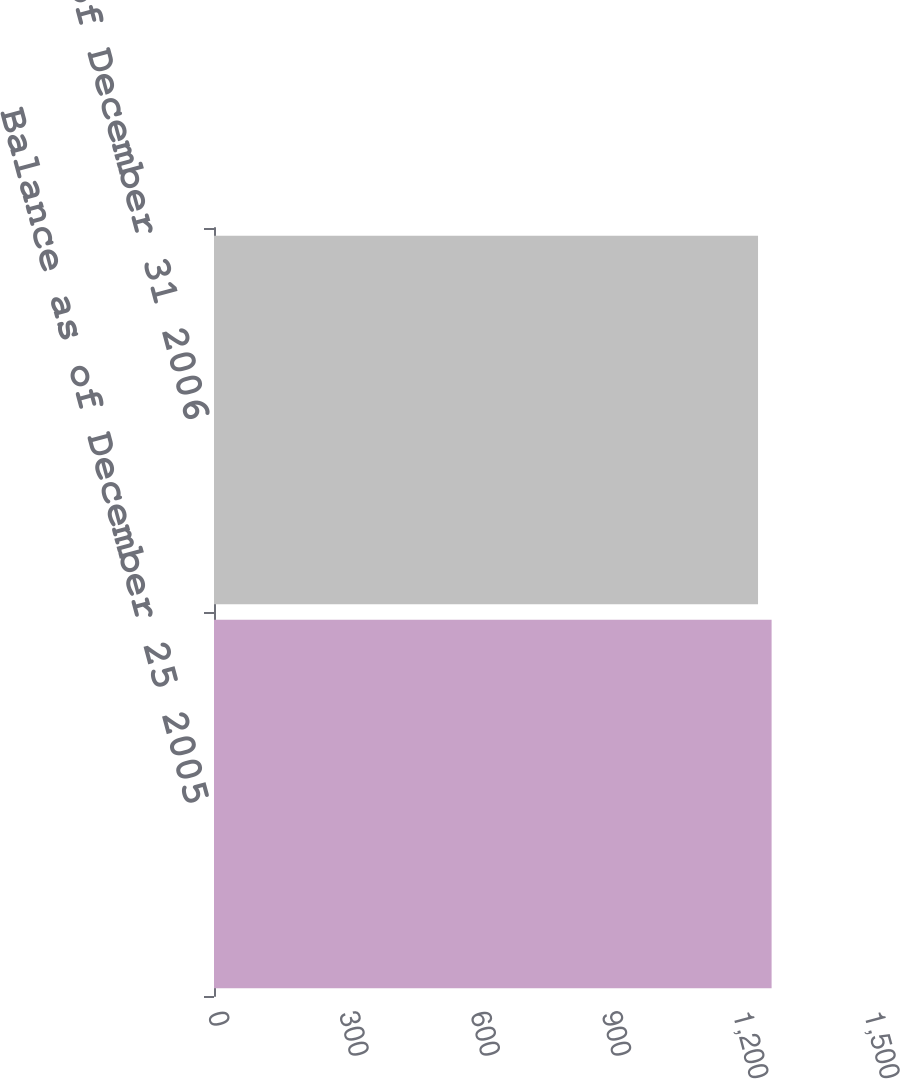<chart> <loc_0><loc_0><loc_500><loc_500><bar_chart><fcel>Balance as of December 25 2005<fcel>Balance as of December 31 2006<nl><fcel>1275<fcel>1244<nl></chart> 